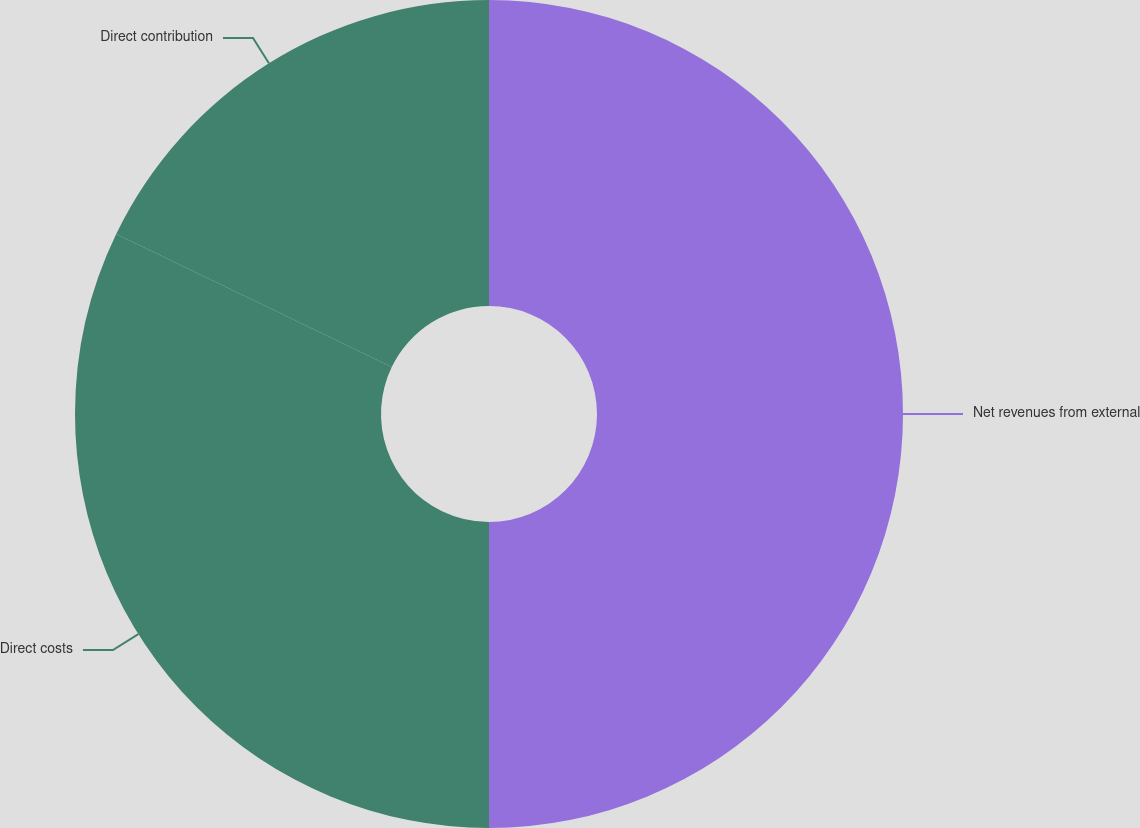Convert chart. <chart><loc_0><loc_0><loc_500><loc_500><pie_chart><fcel>Net revenues from external<fcel>Direct costs<fcel>Direct contribution<nl><fcel>50.0%<fcel>32.16%<fcel>17.84%<nl></chart> 